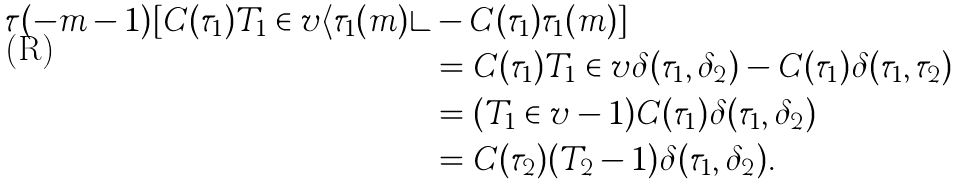<formula> <loc_0><loc_0><loc_500><loc_500>\tau ( - m - 1 ) [ C ( \tau _ { 1 } ) T _ { 1 } \in v \langle \tau _ { 1 } ( m ) \rangle & - C ( \tau _ { 1 } ) \tau _ { 1 } ( m ) ] \\ & = C ( \tau _ { 1 } ) T _ { 1 } \in v \delta ( \tau _ { 1 } , \delta _ { 2 } ) - C ( \tau _ { 1 } ) \delta ( \tau _ { 1 } , \tau _ { 2 } ) \\ & = ( T _ { 1 } \in v - 1 ) C ( \tau _ { 1 } ) \delta ( \tau _ { 1 } , \delta _ { 2 } ) \\ & = C ( \tau _ { 2 } ) ( T _ { 2 } - 1 ) \delta ( \tau _ { 1 } , \delta _ { 2 } ) .</formula> 